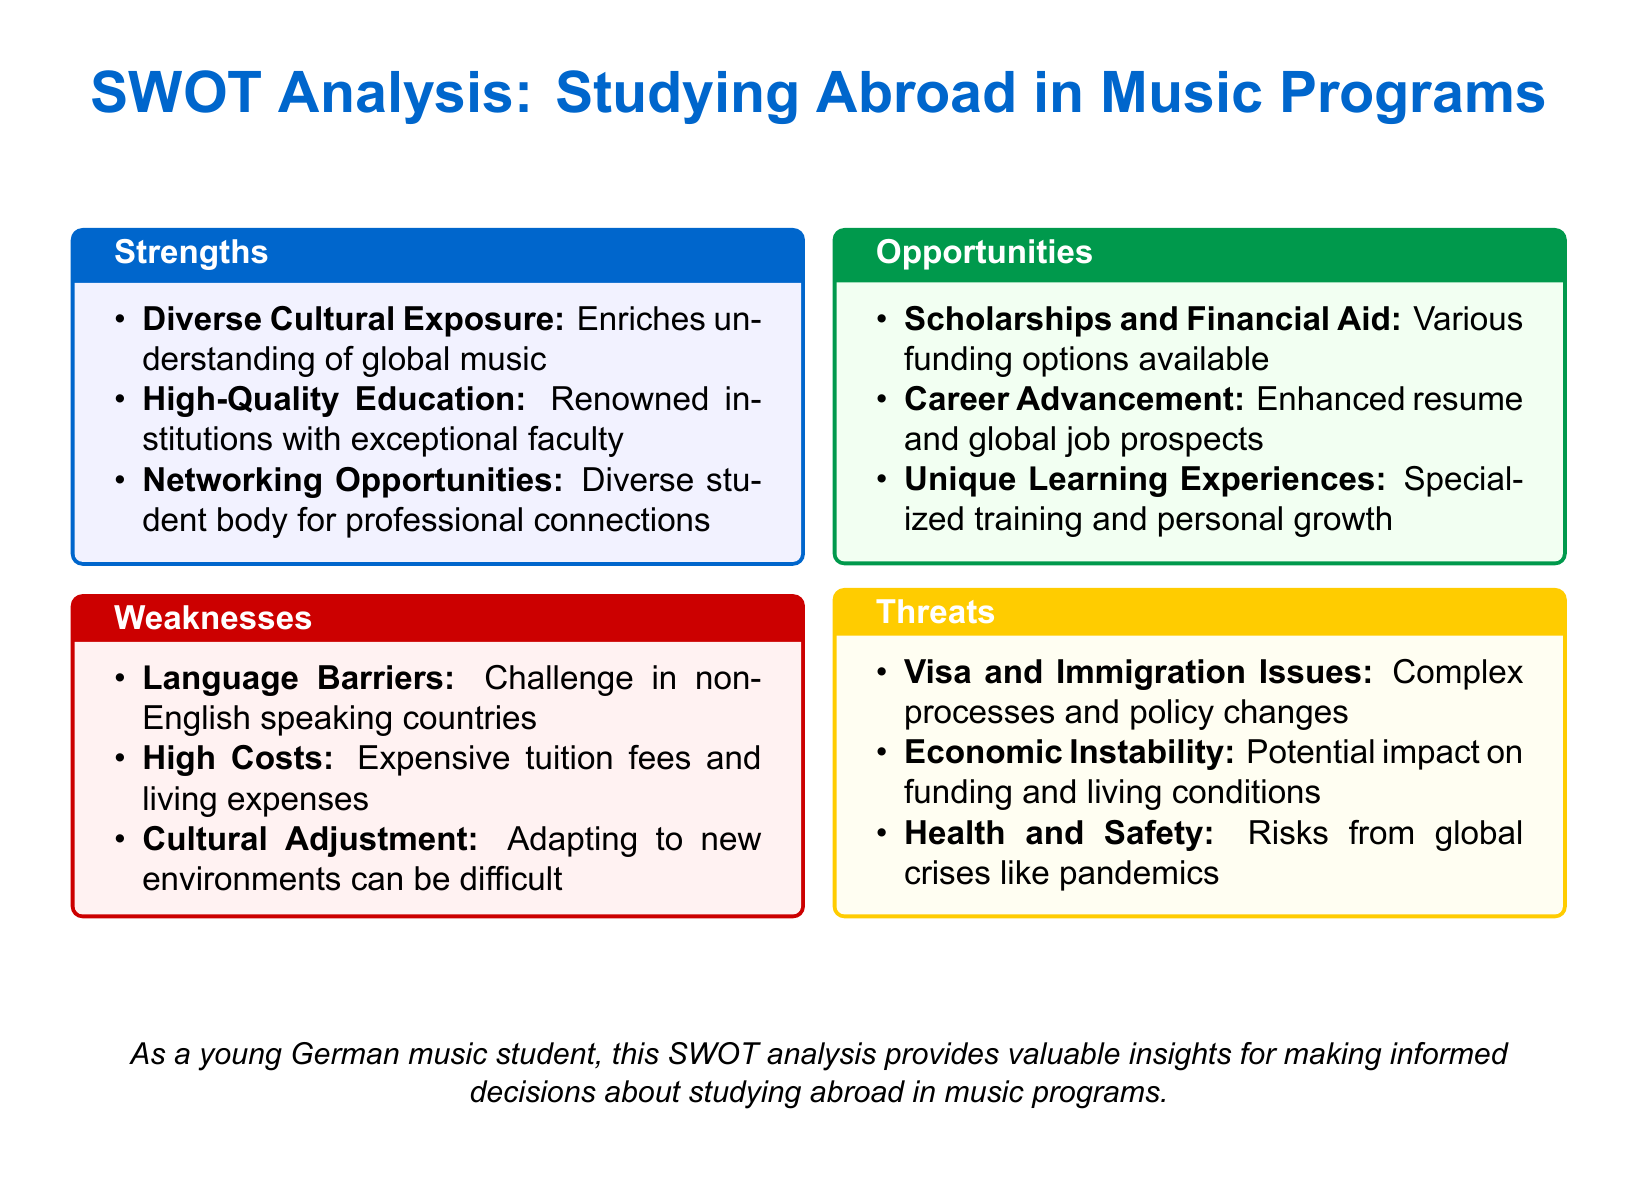What is the title of the document? The title of the document is the main heading found at the beginning, which summarizes the content.
Answer: SWOT Analysis: Studying Abroad in Music Programs How many weaknesses are listed? The document provides three specific weaknesses within the Weaknesses section.
Answer: 3 Name one opportunity for studying abroad. The Opportunities section includes multiple options, and one can be directly extracted.
Answer: Scholarships and Financial Aid What is one strength mentioned related to education quality? The document lists High-Quality Education as a strength referring to renowned institutions.
Answer: High-Quality Education What are the potential risks mentioned in the Threats section? The Threats section outlines specific dangers that are outlined clearly in the text.
Answer: Health and Safety What aspect of studying abroad can enhance job prospects? The document emphasizes Career Advancement as an outcome of studying abroad.
Answer: Career Advancement What color is used for the Strengths section? The document specifies the color used for the heading of the Strengths section and doesn't require deeper reasoning to answer.
Answer: myblue Which category mentions complex processes? The Threats section specifically addresses the complexity of processes related to visa and immigration.
Answer: Threats What is a unique learning aspect highlighted? The document lists Unique Learning Experiences as one of the key opportunities, indicating a specific educational benefit.
Answer: Unique Learning Experiences 